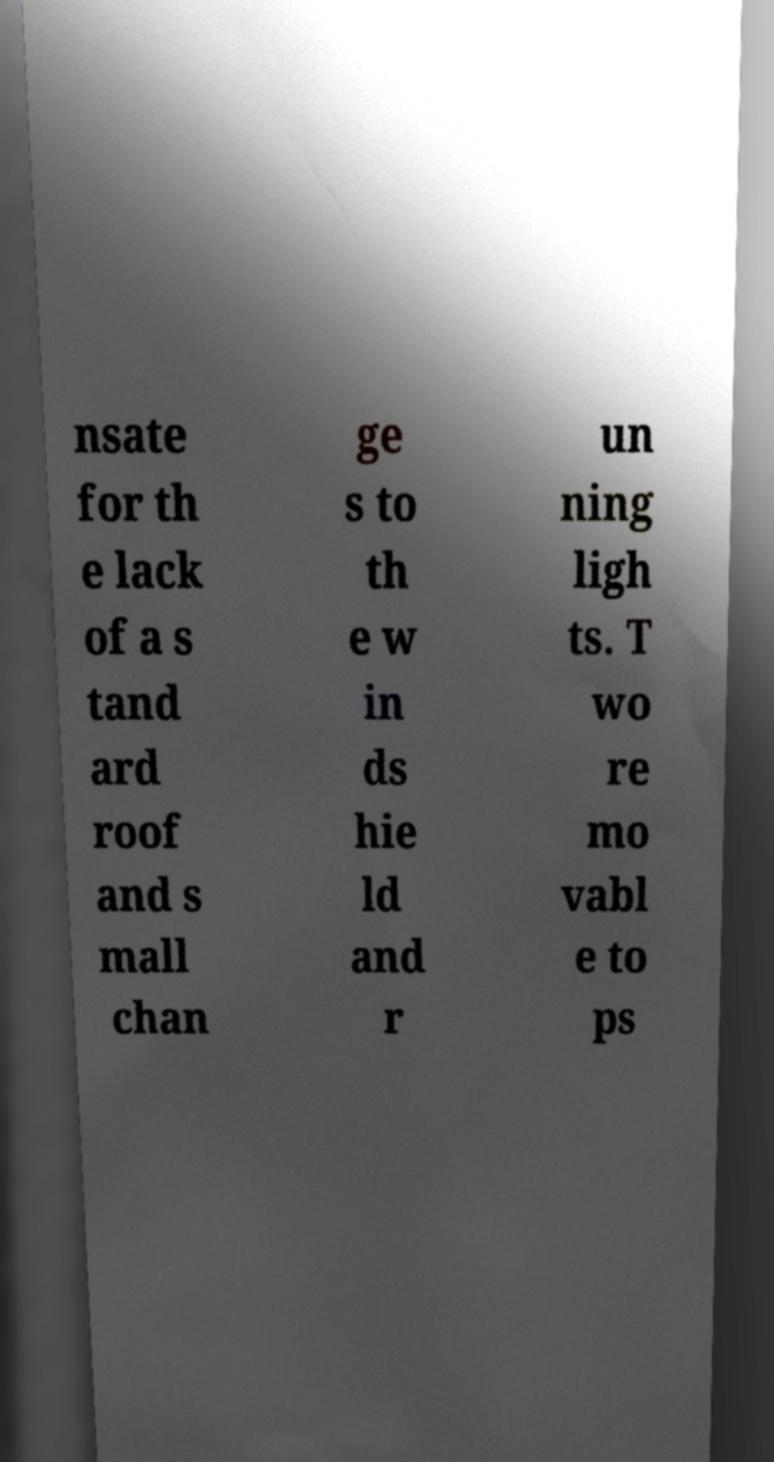Can you accurately transcribe the text from the provided image for me? nsate for th e lack of a s tand ard roof and s mall chan ge s to th e w in ds hie ld and r un ning ligh ts. T wo re mo vabl e to ps 